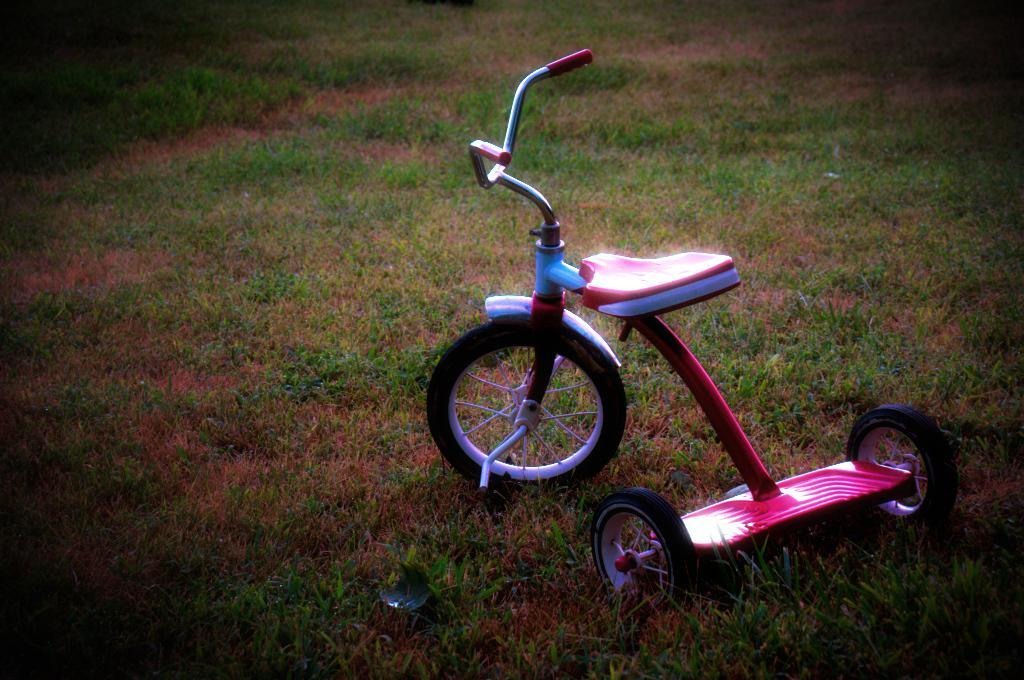What type of vehicle is in the picture? There is a small bicycle in the picture. What colors are used for the bicycle? The bicycle is blue and pink in color. Where is the bicycle located in the image? The bicycle is on the ground. What type of surface is the bicycle resting on? There is grass on the ground. Can you hear the horn of the bicycle in the image? There is no mention of a horn in the image, so it cannot be heard. 